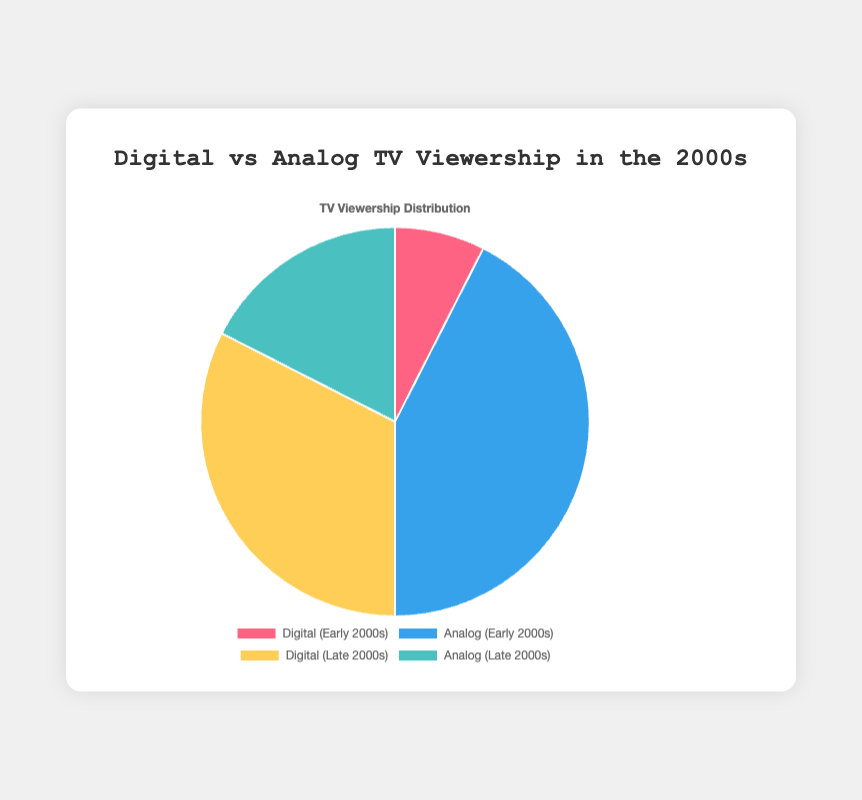Which period had a higher viewership of digital TV, the early or late 2000s? Compare the data points: Digital (Early 2000s) is 15, and Digital (Late 2000s) is 65. Therefore, the late 2000s had higher digital TV viewership.
Answer: Late 2000s What percentage of TV viewership was analog in the early 2000s? The chart shows Analog (Early 2000s) as 85. Since the total percentage for both digital and analog in the early 2000s is 100, the analog viewership percentage in the early 2000s is 85%.
Answer: 85% What is the combined percentage of digital TV viewership in the early and late 2000s? Sum the digital viewership percentages from both periods: 15 (Early 2000s) + 65 (Late 2000s) = 80.
Answer: 80% What is the difference in analog TV viewership between the early and late 2000s? Subtract the analog viewership in the late 2000s (35) from that in the early 2000s (85): 85 - 35 = 50.
Answer: 50 Which segment is represented by the yellow color in the pie chart? The chart uses yellow for one of the segments, which the labels indicate is 'Digital (Late 2000s)'.
Answer: Digital (Late 2000s) How did analog TV viewership change from the early to the late 2000s? Analog viewership went from 85 in the early 2000s to 35 in the late 2000s, representing a decrease.
Answer: Decreased Which type of TV viewership had a larger share in the late 2000s? Comparing the late 2000s segments, Digital has 65, and Analog has 35. Digital had a larger share in the late 2000s.
Answer: Digital How much did digital TV viewership increase from the early to the late 2000s? Subtract the digital viewership in the early 2000s (15) from that in the late 2000s (65): 65 - 15 = 50.
Answer: 50 